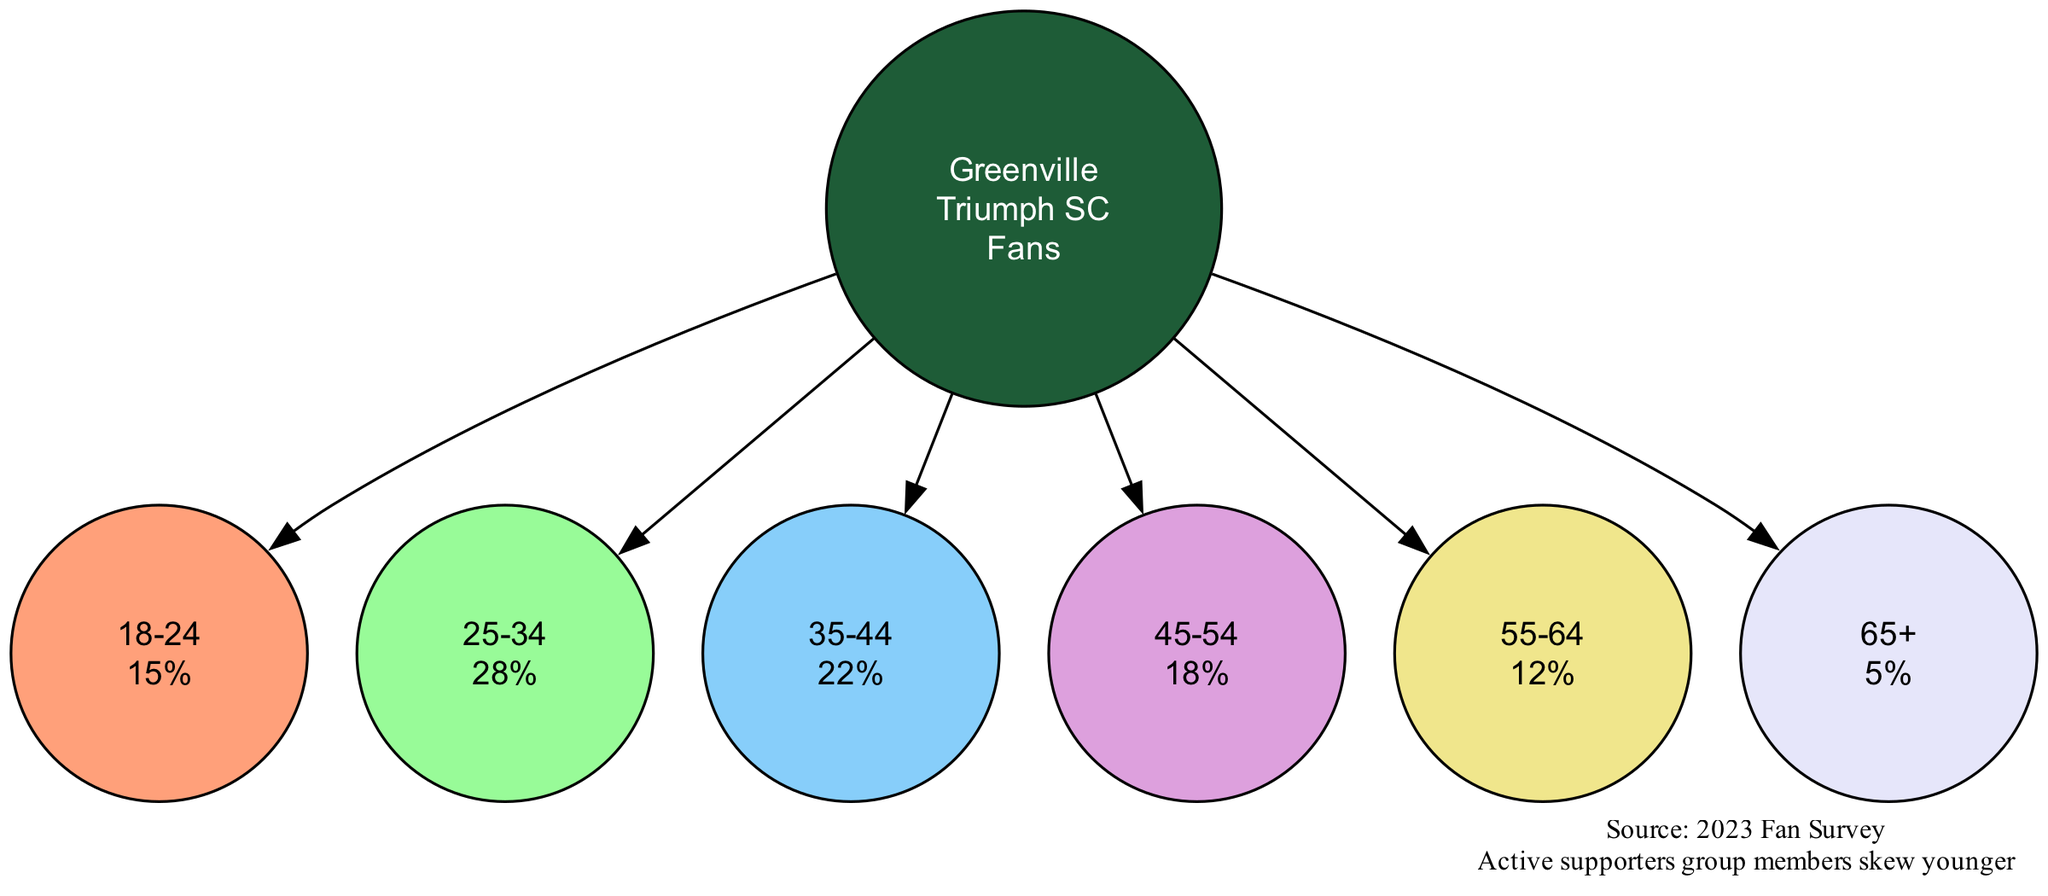What is the percentage of fans aged 25-34? In the diagram, the age group for 25-34 years shows a percentage next to it. This percentage is clearly labeled in the respective node, which indicates that 28% of fans fall within this age range.
Answer: 28% How many age groups are represented in the pie chart? To find the number of age groups, we can count the distinct nodes that are connected to the center node. There are six age groups displayed in the diagram, indicating a total of six different demographic segments.
Answer: 6 What is the total percentage of fans aged 55 and older? To find the total percentage of fans aged 55 and older, we first identify the age groups in this range: 55-64 (12%) and 65+ (5%). Adding these two percentages gives 12% + 5% = 17%.
Answer: 17% Which age group has the highest percentage of fans? The highest percentage can be determined by comparing the percentages listed next to each age group node. The age group of 25-34 years has the highest percentage at 28%.
Answer: 25-34 What does the note in the diagram indicate about the supporters' group? The note states that "Active supporters group members skew younger," which implies that younger fans are more likely to be members of the supporters' group compared to older fans. This shows a trend in the demographic makeup.
Answer: Skew younger What percentage of fans are aged 65 and older? The diagram directly indicates the percentage for the age group of 65+, which is labeled within its respective node. It shows that 5% of the fans are in this age category.
Answer: 5% Which age group has the lowest representation in the fan demographics? By examining the percentages presented in each age group node, it's clear that the age group of 65+ has the lowest percentage at 5%, representing the smallest segment of the fan base.
Answer: 65+ 